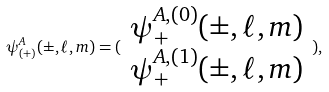<formula> <loc_0><loc_0><loc_500><loc_500>\psi _ { ( + ) } ^ { A } ( \pm , \ell , m ) = ( \begin{array} { c } \psi _ { + } ^ { A , ( 0 ) } ( \pm , \ell , m ) \\ \psi _ { + } ^ { A , ( 1 ) } ( \pm , \ell , m ) \end{array} ) ,</formula> 